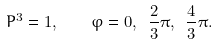Convert formula to latex. <formula><loc_0><loc_0><loc_500><loc_500>P ^ { 3 } = 1 , \quad \varphi = 0 , \ \frac { 2 } { 3 } \pi , \ \frac { 4 } { 3 } \pi .</formula> 